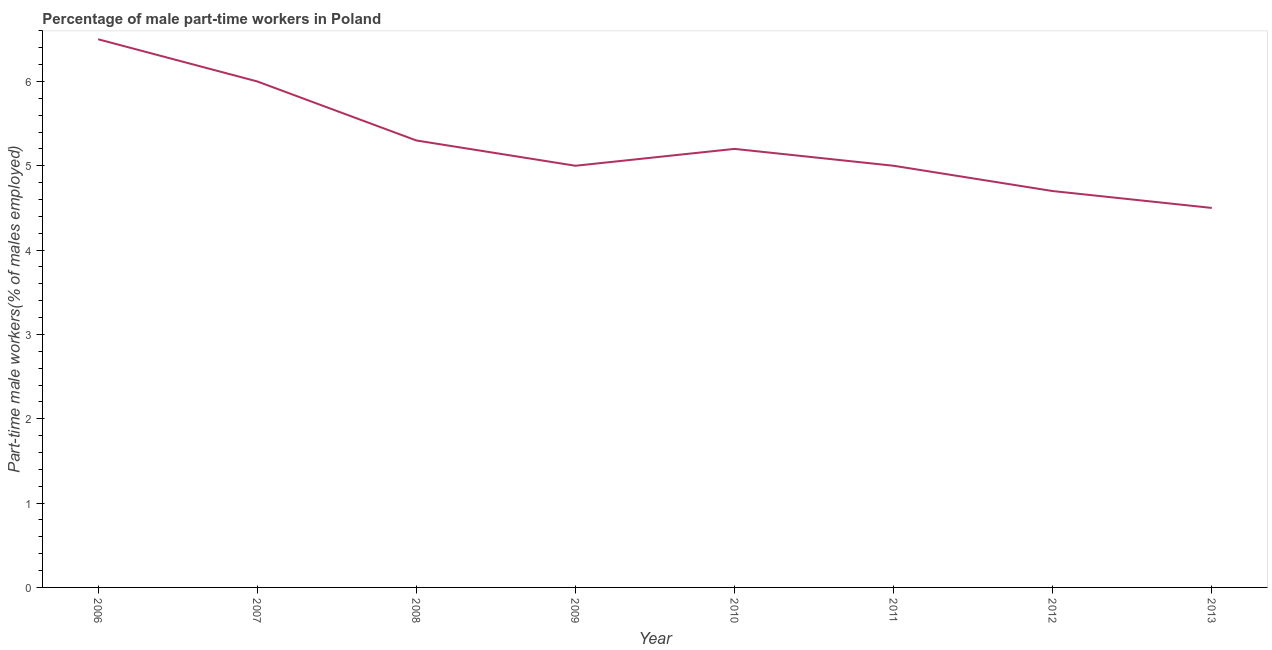What is the percentage of part-time male workers in 2007?
Offer a very short reply. 6. Across all years, what is the maximum percentage of part-time male workers?
Provide a succinct answer. 6.5. Across all years, what is the minimum percentage of part-time male workers?
Provide a succinct answer. 4.5. In which year was the percentage of part-time male workers maximum?
Your answer should be very brief. 2006. What is the sum of the percentage of part-time male workers?
Provide a succinct answer. 42.2. What is the difference between the percentage of part-time male workers in 2011 and 2012?
Your answer should be very brief. 0.3. What is the average percentage of part-time male workers per year?
Offer a terse response. 5.27. What is the median percentage of part-time male workers?
Make the answer very short. 5.1. What is the difference between the highest and the lowest percentage of part-time male workers?
Provide a short and direct response. 2. In how many years, is the percentage of part-time male workers greater than the average percentage of part-time male workers taken over all years?
Make the answer very short. 3. Does the percentage of part-time male workers monotonically increase over the years?
Your answer should be compact. No. Are the values on the major ticks of Y-axis written in scientific E-notation?
Provide a short and direct response. No. What is the title of the graph?
Your response must be concise. Percentage of male part-time workers in Poland. What is the label or title of the Y-axis?
Your answer should be compact. Part-time male workers(% of males employed). What is the Part-time male workers(% of males employed) of 2006?
Provide a succinct answer. 6.5. What is the Part-time male workers(% of males employed) in 2007?
Your answer should be compact. 6. What is the Part-time male workers(% of males employed) in 2008?
Make the answer very short. 5.3. What is the Part-time male workers(% of males employed) in 2010?
Make the answer very short. 5.2. What is the Part-time male workers(% of males employed) in 2012?
Keep it short and to the point. 4.7. What is the difference between the Part-time male workers(% of males employed) in 2006 and 2008?
Keep it short and to the point. 1.2. What is the difference between the Part-time male workers(% of males employed) in 2006 and 2009?
Your response must be concise. 1.5. What is the difference between the Part-time male workers(% of males employed) in 2006 and 2011?
Your answer should be very brief. 1.5. What is the difference between the Part-time male workers(% of males employed) in 2006 and 2013?
Keep it short and to the point. 2. What is the difference between the Part-time male workers(% of males employed) in 2007 and 2009?
Provide a succinct answer. 1. What is the difference between the Part-time male workers(% of males employed) in 2007 and 2010?
Your response must be concise. 0.8. What is the difference between the Part-time male workers(% of males employed) in 2007 and 2011?
Provide a succinct answer. 1. What is the difference between the Part-time male workers(% of males employed) in 2007 and 2013?
Your answer should be very brief. 1.5. What is the difference between the Part-time male workers(% of males employed) in 2008 and 2011?
Offer a terse response. 0.3. What is the difference between the Part-time male workers(% of males employed) in 2008 and 2012?
Give a very brief answer. 0.6. What is the difference between the Part-time male workers(% of males employed) in 2009 and 2010?
Offer a terse response. -0.2. What is the difference between the Part-time male workers(% of males employed) in 2009 and 2011?
Offer a very short reply. 0. What is the difference between the Part-time male workers(% of males employed) in 2010 and 2011?
Provide a short and direct response. 0.2. What is the difference between the Part-time male workers(% of males employed) in 2010 and 2012?
Offer a terse response. 0.5. What is the difference between the Part-time male workers(% of males employed) in 2010 and 2013?
Offer a very short reply. 0.7. What is the ratio of the Part-time male workers(% of males employed) in 2006 to that in 2007?
Offer a terse response. 1.08. What is the ratio of the Part-time male workers(% of males employed) in 2006 to that in 2008?
Provide a short and direct response. 1.23. What is the ratio of the Part-time male workers(% of males employed) in 2006 to that in 2009?
Your response must be concise. 1.3. What is the ratio of the Part-time male workers(% of males employed) in 2006 to that in 2010?
Provide a short and direct response. 1.25. What is the ratio of the Part-time male workers(% of males employed) in 2006 to that in 2011?
Provide a succinct answer. 1.3. What is the ratio of the Part-time male workers(% of males employed) in 2006 to that in 2012?
Your response must be concise. 1.38. What is the ratio of the Part-time male workers(% of males employed) in 2006 to that in 2013?
Ensure brevity in your answer.  1.44. What is the ratio of the Part-time male workers(% of males employed) in 2007 to that in 2008?
Your answer should be compact. 1.13. What is the ratio of the Part-time male workers(% of males employed) in 2007 to that in 2009?
Offer a terse response. 1.2. What is the ratio of the Part-time male workers(% of males employed) in 2007 to that in 2010?
Offer a very short reply. 1.15. What is the ratio of the Part-time male workers(% of males employed) in 2007 to that in 2011?
Provide a succinct answer. 1.2. What is the ratio of the Part-time male workers(% of males employed) in 2007 to that in 2012?
Ensure brevity in your answer.  1.28. What is the ratio of the Part-time male workers(% of males employed) in 2007 to that in 2013?
Ensure brevity in your answer.  1.33. What is the ratio of the Part-time male workers(% of males employed) in 2008 to that in 2009?
Ensure brevity in your answer.  1.06. What is the ratio of the Part-time male workers(% of males employed) in 2008 to that in 2011?
Provide a short and direct response. 1.06. What is the ratio of the Part-time male workers(% of males employed) in 2008 to that in 2012?
Keep it short and to the point. 1.13. What is the ratio of the Part-time male workers(% of males employed) in 2008 to that in 2013?
Offer a terse response. 1.18. What is the ratio of the Part-time male workers(% of males employed) in 2009 to that in 2012?
Provide a short and direct response. 1.06. What is the ratio of the Part-time male workers(% of males employed) in 2009 to that in 2013?
Provide a succinct answer. 1.11. What is the ratio of the Part-time male workers(% of males employed) in 2010 to that in 2012?
Ensure brevity in your answer.  1.11. What is the ratio of the Part-time male workers(% of males employed) in 2010 to that in 2013?
Your response must be concise. 1.16. What is the ratio of the Part-time male workers(% of males employed) in 2011 to that in 2012?
Your answer should be very brief. 1.06. What is the ratio of the Part-time male workers(% of males employed) in 2011 to that in 2013?
Make the answer very short. 1.11. What is the ratio of the Part-time male workers(% of males employed) in 2012 to that in 2013?
Your answer should be compact. 1.04. 